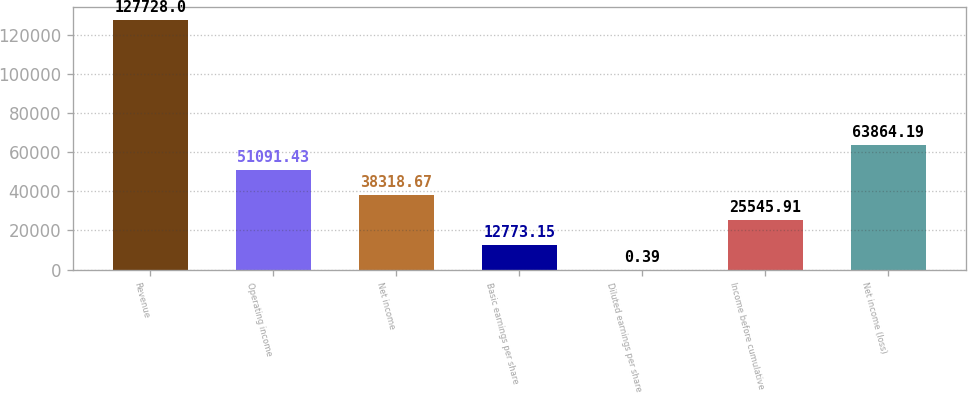<chart> <loc_0><loc_0><loc_500><loc_500><bar_chart><fcel>Revenue<fcel>Operating income<fcel>Net income<fcel>Basic earnings per share<fcel>Diluted earnings per share<fcel>Income before cumulative<fcel>Net income (loss)<nl><fcel>127728<fcel>51091.4<fcel>38318.7<fcel>12773.1<fcel>0.39<fcel>25545.9<fcel>63864.2<nl></chart> 